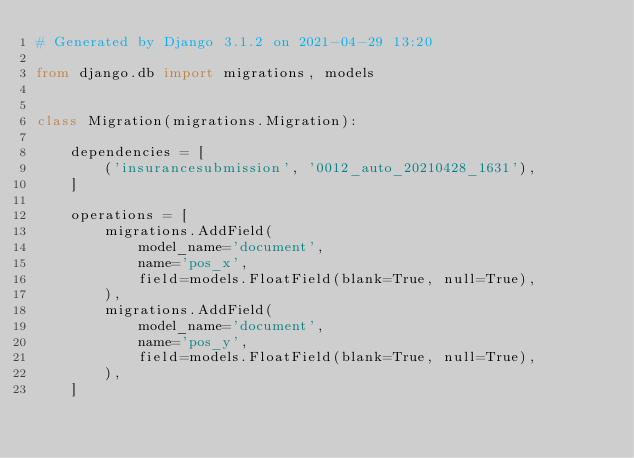<code> <loc_0><loc_0><loc_500><loc_500><_Python_># Generated by Django 3.1.2 on 2021-04-29 13:20

from django.db import migrations, models


class Migration(migrations.Migration):

    dependencies = [
        ('insurancesubmission', '0012_auto_20210428_1631'),
    ]

    operations = [
        migrations.AddField(
            model_name='document',
            name='pos_x',
            field=models.FloatField(blank=True, null=True),
        ),
        migrations.AddField(
            model_name='document',
            name='pos_y',
            field=models.FloatField(blank=True, null=True),
        ),
    ]
</code> 